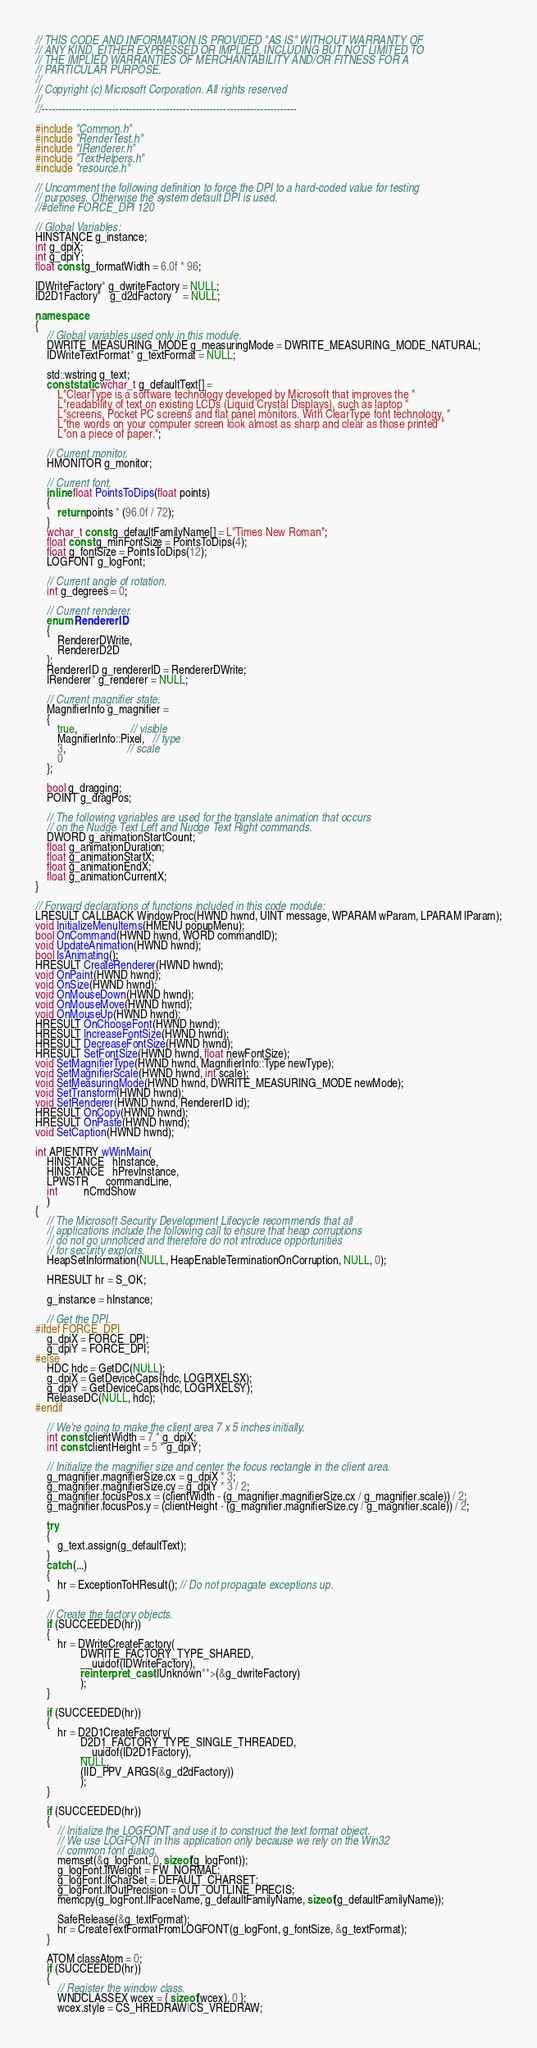<code> <loc_0><loc_0><loc_500><loc_500><_C++_>// THIS CODE AND INFORMATION IS PROVIDED "AS IS" WITHOUT WARRANTY OF
// ANY KIND, EITHER EXPRESSED OR IMPLIED, INCLUDING BUT NOT LIMITED TO
// THE IMPLIED WARRANTIES OF MERCHANTABILITY AND/OR FITNESS FOR A
// PARTICULAR PURPOSE.
//
// Copyright (c) Microsoft Corporation. All rights reserved
//
//----------------------------------------------------------------------------

#include "Common.h"
#include "RenderTest.h"
#include "IRenderer.h"
#include "TextHelpers.h"
#include "resource.h"

// Uncomment the following definition to force the DPI to a hard-coded value for testing
// purposes. Otherwise the system default DPI is used.
//#define FORCE_DPI 120

// Global Variables:
HINSTANCE g_instance;
int g_dpiX;
int g_dpiY;
float const g_formatWidth = 6.0f * 96;

IDWriteFactory* g_dwriteFactory = NULL;
ID2D1Factory*   g_d2dFactory    = NULL;

namespace
{
    // Global variables used only in this module.
    DWRITE_MEASURING_MODE g_measuringMode = DWRITE_MEASURING_MODE_NATURAL;
    IDWriteTextFormat* g_textFormat = NULL;

    std::wstring g_text;
    const static wchar_t g_defaultText[] =
        L"ClearType is a software technology developed by Microsoft that improves the "
        L"readability of text on existing LCDs (Liquid Crystal Displays), such as laptop "
        L"screens, Pocket PC screens and flat panel monitors. With ClearType font technology, "
        L"the words on your computer screen look almost as sharp and clear as those printed "
        L"on a piece of paper.";

    // Current monitor.
    HMONITOR g_monitor;

    // Current font.
    inline float PointsToDips(float points)
    {
        return points * (96.0f / 72);
    }
    wchar_t const g_defaultFamilyName[] = L"Times New Roman";
    float const g_minFontSize = PointsToDips(4);
    float g_fontSize = PointsToDips(12);
    LOGFONT g_logFont;

    // Current angle of rotation.
    int g_degrees = 0;

    // Current renderer.
    enum RendererID
    {
        RendererDWrite,
        RendererD2D
    };
    RendererID g_rendererID = RendererDWrite;
    IRenderer* g_renderer = NULL;

    // Current magnifier state.
    MagnifierInfo g_magnifier =
    {
        true,                   // visible
        MagnifierInfo::Pixel,   // type
        3,                      // scale
        0
    };

    bool g_dragging;
    POINT g_dragPos;

    // The following variables are used for the translate animation that occurs
    // on the Nudge Text Left and Nudge Text Right commands.
    DWORD g_animationStartCount;
    float g_animationDuration;
    float g_animationStartX;
    float g_animationEndX;
    float g_animationCurrentX;
}

// Forward declarations of functions included in this code module:
LRESULT CALLBACK WindowProc(HWND hwnd, UINT message, WPARAM wParam, LPARAM lParam);
void InitializeMenuItems(HMENU popupMenu);
bool OnCommand(HWND hwnd, WORD commandID);
void UpdateAnimation(HWND hwnd);
bool IsAnimating();
HRESULT CreateRenderer(HWND hwnd);
void OnPaint(HWND hwnd);
void OnSize(HWND hwnd);
void OnMouseDown(HWND hwnd);
void OnMouseMove(HWND hwnd);
void OnMouseUp(HWND hwnd);
HRESULT OnChooseFont(HWND hwnd);
HRESULT IncreaseFontSize(HWND hwnd);
HRESULT DecreaseFontSize(HWND hwnd);
HRESULT SetFontSize(HWND hwnd, float newFontSize);
void SetMagnifierType(HWND hwnd, MagnifierInfo::Type newType);
void SetMagnifierScale(HWND hwnd, int scale);
void SetMeasuringMode(HWND hwnd, DWRITE_MEASURING_MODE newMode);
void SetTransform(HWND hwnd);
void SetRenderer(HWND hwnd, RendererID id);
HRESULT OnCopy(HWND hwnd);
HRESULT OnPaste(HWND hwnd);
void SetCaption(HWND hwnd);

int APIENTRY wWinMain(
    HINSTANCE   hInstance, 
    HINSTANCE   hPrevInstance,
    LPWSTR      commandLine,
    int         nCmdShow
    )
{
    // The Microsoft Security Development Lifecycle recommends that all
    // applications include the following call to ensure that heap corruptions
    // do not go unnoticed and therefore do not introduce opportunities
    // for security exploits.
    HeapSetInformation(NULL, HeapEnableTerminationOnCorruption, NULL, 0);

    HRESULT hr = S_OK;

    g_instance = hInstance;

    // Get the DPI.
#ifdef FORCE_DPI
    g_dpiX = FORCE_DPI;
    g_dpiY = FORCE_DPI;
#else
    HDC hdc = GetDC(NULL);
    g_dpiX = GetDeviceCaps(hdc, LOGPIXELSX);
    g_dpiY = GetDeviceCaps(hdc, LOGPIXELSY);
    ReleaseDC(NULL, hdc);
#endif

    // We're going to make the client area 7 x 5 inches initially.
    int const clientWidth = 7 * g_dpiX;
    int const clientHeight = 5 * g_dpiY;

    // Initialize the magnifier size and center the focus rectangle in the client area.
    g_magnifier.magnifierSize.cx = g_dpiX * 3;
    g_magnifier.magnifierSize.cy = g_dpiY * 3 / 2;
    g_magnifier.focusPos.x = (clientWidth - (g_magnifier.magnifierSize.cx / g_magnifier.scale)) / 2;
    g_magnifier.focusPos.y = (clientHeight - (g_magnifier.magnifierSize.cy / g_magnifier.scale)) / 2;

    try
    {
        g_text.assign(g_defaultText);
    }
    catch (...)
    {
        hr = ExceptionToHResult(); // Do not propagate exceptions up.
    }

    // Create the factory objects.
    if (SUCCEEDED(hr))
    {
        hr = DWriteCreateFactory(
                DWRITE_FACTORY_TYPE_SHARED, 
                __uuidof(IDWriteFactory), 
                reinterpret_cast<IUnknown**>(&g_dwriteFactory)
                );
    }

    if (SUCCEEDED(hr))
    {
        hr = D2D1CreateFactory(
                D2D1_FACTORY_TYPE_SINGLE_THREADED, 
                __uuidof(ID2D1Factory), 
                NULL,
                (IID_PPV_ARGS(&g_d2dFactory))
                );
    }

    if (SUCCEEDED(hr))
    {
        // Initialize the LOGFONT and use it to construct the text format object.
        // We use LOGFONT in this application only because we rely on the Win32 
        // common font dialog.
        memset(&g_logFont, 0, sizeof(g_logFont));
        g_logFont.lfWeight = FW_NORMAL;
        g_logFont.lfCharSet = DEFAULT_CHARSET;
        g_logFont.lfOutPrecision = OUT_OUTLINE_PRECIS;
        memcpy(g_logFont.lfFaceName, g_defaultFamilyName, sizeof(g_defaultFamilyName));

        SafeRelease(&g_textFormat);
        hr = CreateTextFormatFromLOGFONT(g_logFont, g_fontSize, &g_textFormat);
    }

    ATOM classAtom = 0;
    if (SUCCEEDED(hr))
    {
        // Register the window class.
        WNDCLASSEX wcex = { sizeof(wcex), 0 };
        wcex.style = CS_HREDRAW|CS_VREDRAW;</code> 